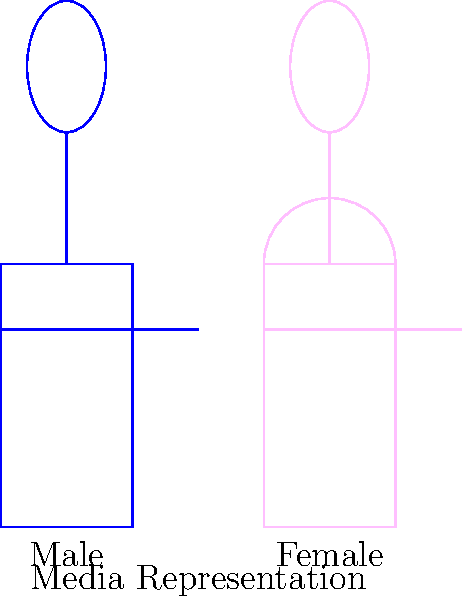Analyze the image above, which represents typical media portrayals of male and female characters. How does this visual representation reinforce gender stereotypes, and what potential impact might this have on viewers' perceptions of gender roles? 1. Visual Analysis:
   - Male character: Depicted with straight lines, angular shape, and blue color.
   - Female character: Shown with curved lines, emphasizing chest area, and pink color.

2. Stereotype Reinforcement:
   - Color coding: Blue for male, pink for female perpetuates traditional gender color associations.
   - Body shape: Male figure is more rectangular, while female figure has exaggerated curves, reinforcing idealized body types.

3. Symbolic Representation:
   - Straight lines for male suggest strength, rigidity, and rationality.
   - Curved lines for female imply softness, emotionality, and nurturing qualities.

4. Media Impact:
   - These representations can shape viewers' expectations of how men and women should look and behave.
   - Repeated exposure to such imagery may lead to internalization of stereotypes.

5. Societal Implications:
   - Reinforces binary gender norms, excluding non-binary and gender non-conforming individuals.
   - May contribute to body image issues and unrealistic beauty standards.

6. Critical Thinking:
   - Encourages viewers to question why media consistently portrays genders in these ways.
   - Highlights the need for more diverse and nuanced representations in media.

7. Potential Consequences:
   - Limited role models for individuals who don't fit these stereotypes.
   - Perpetuation of gender-based discrimination and bias in various social contexts.
Answer: The image reinforces gender stereotypes through color, shape, and symbolism, potentially impacting viewers' perceptions of gender roles and perpetuating harmful societal norms. 